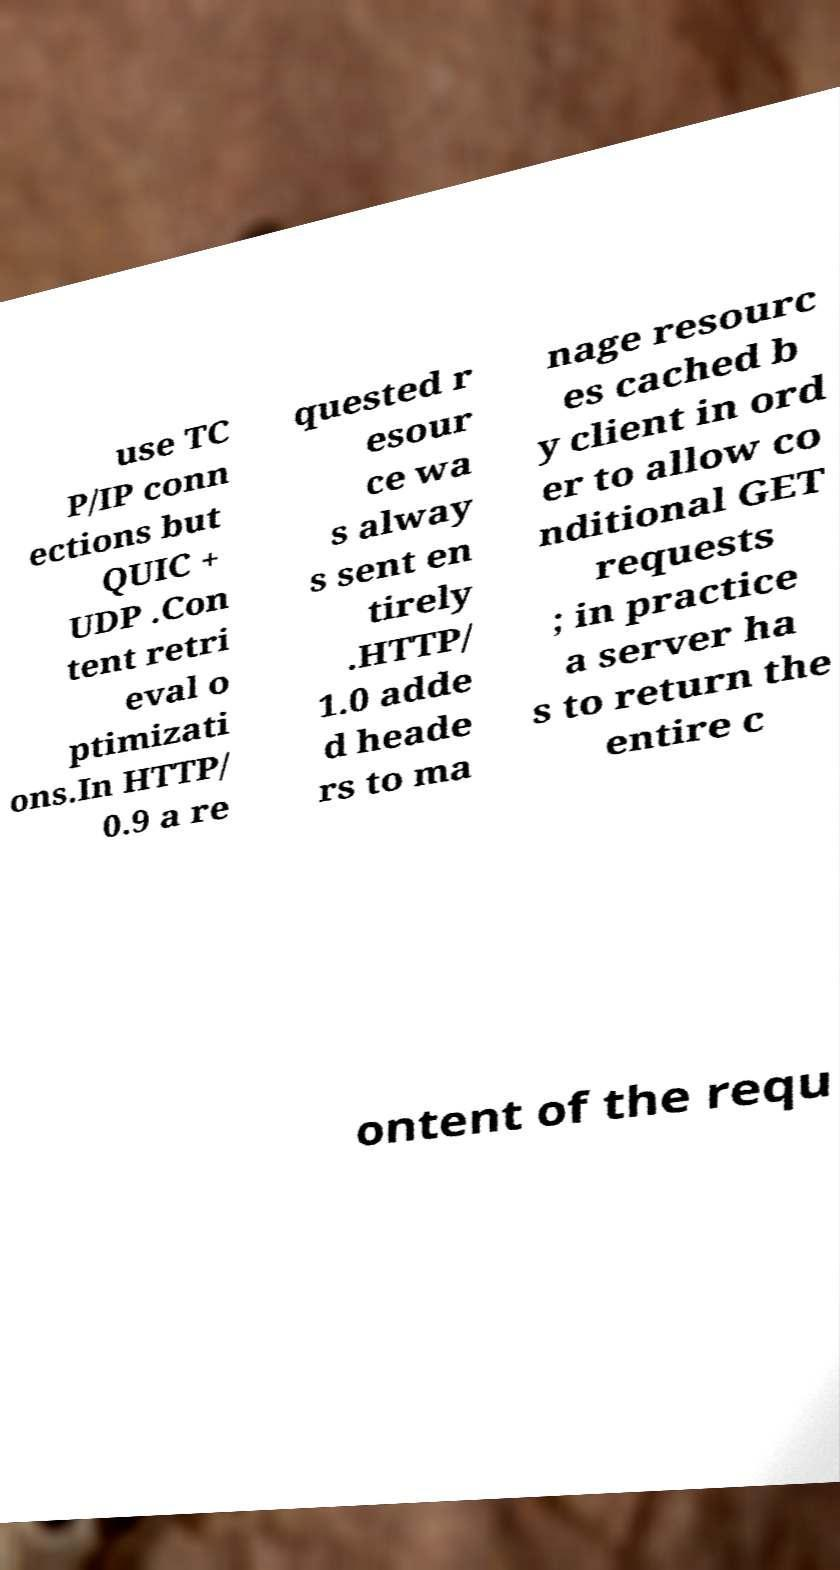Could you extract and type out the text from this image? use TC P/IP conn ections but QUIC + UDP .Con tent retri eval o ptimizati ons.In HTTP/ 0.9 a re quested r esour ce wa s alway s sent en tirely .HTTP/ 1.0 adde d heade rs to ma nage resourc es cached b y client in ord er to allow co nditional GET requests ; in practice a server ha s to return the entire c ontent of the requ 